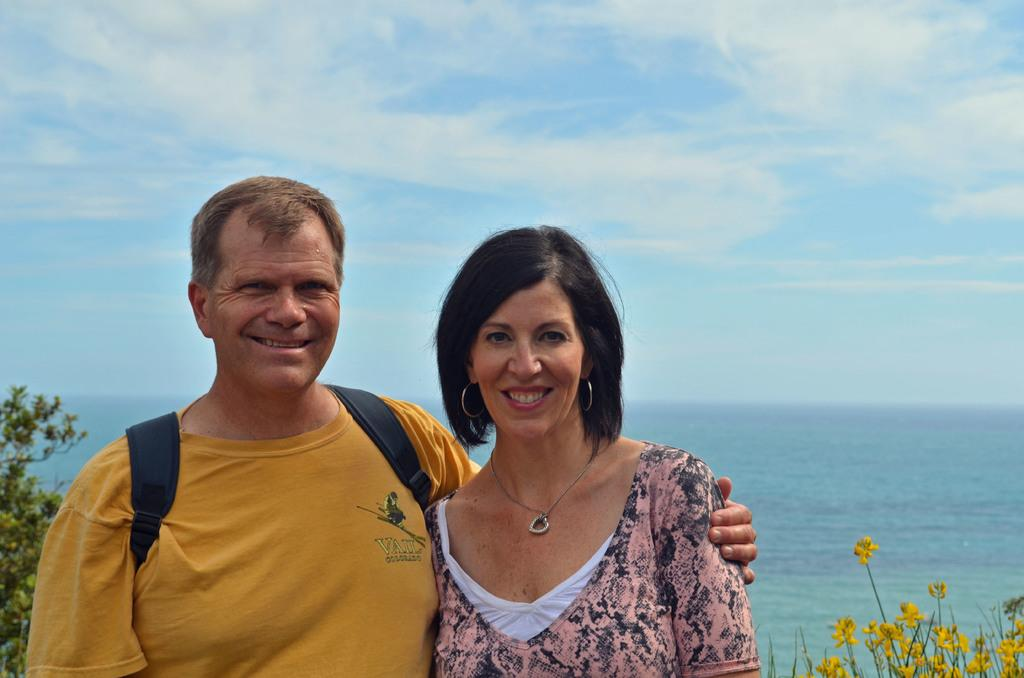What is the person in the image wearing? The person is wearing a yellow T-shirt in the image. What is the person carrying on their back? The person is wearing a backpack. Can you describe the woman in the image? There is a woman in the image, and both the person and the woman are smiling. What can be seen in the background of the image? In the background of the image, there are flowers, trees, water, and the sky. What is the condition of the sky in the image? The sky is visible in the background of the image, and there are clouds present. What type of food is the person eating in the image? There is no food present in the image; the person is wearing a yellow T-shirt and a backpack. Can you tell me how the father is interacting with the person in the image? There is no mention of a father in the image, only a person and a woman. 